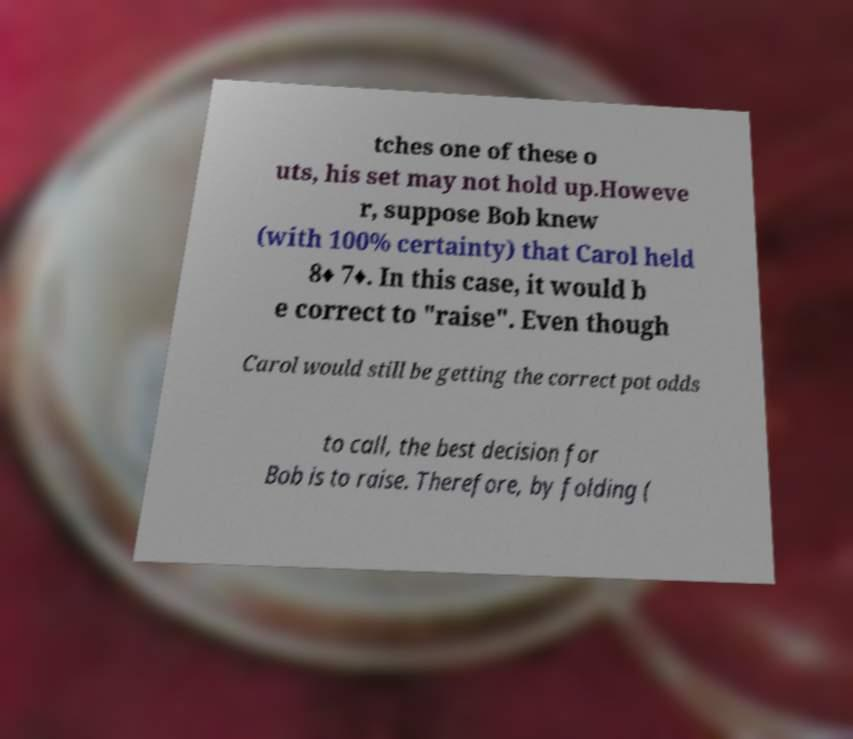Could you assist in decoding the text presented in this image and type it out clearly? tches one of these o uts, his set may not hold up.Howeve r, suppose Bob knew (with 100% certainty) that Carol held 8♦ 7♦. In this case, it would b e correct to "raise". Even though Carol would still be getting the correct pot odds to call, the best decision for Bob is to raise. Therefore, by folding ( 